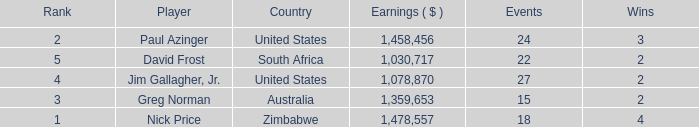How many events are in South Africa? 22.0. 